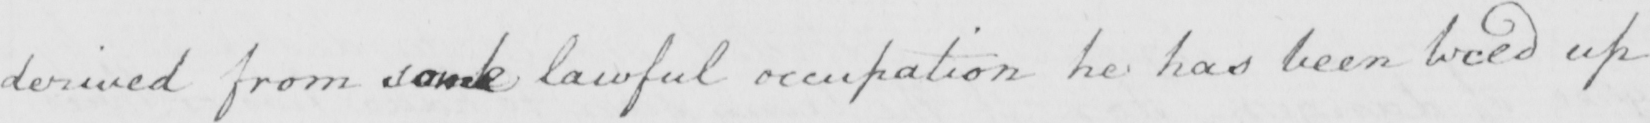What is written in this line of handwriting? derived from some lawful occupation he has been tieed up 